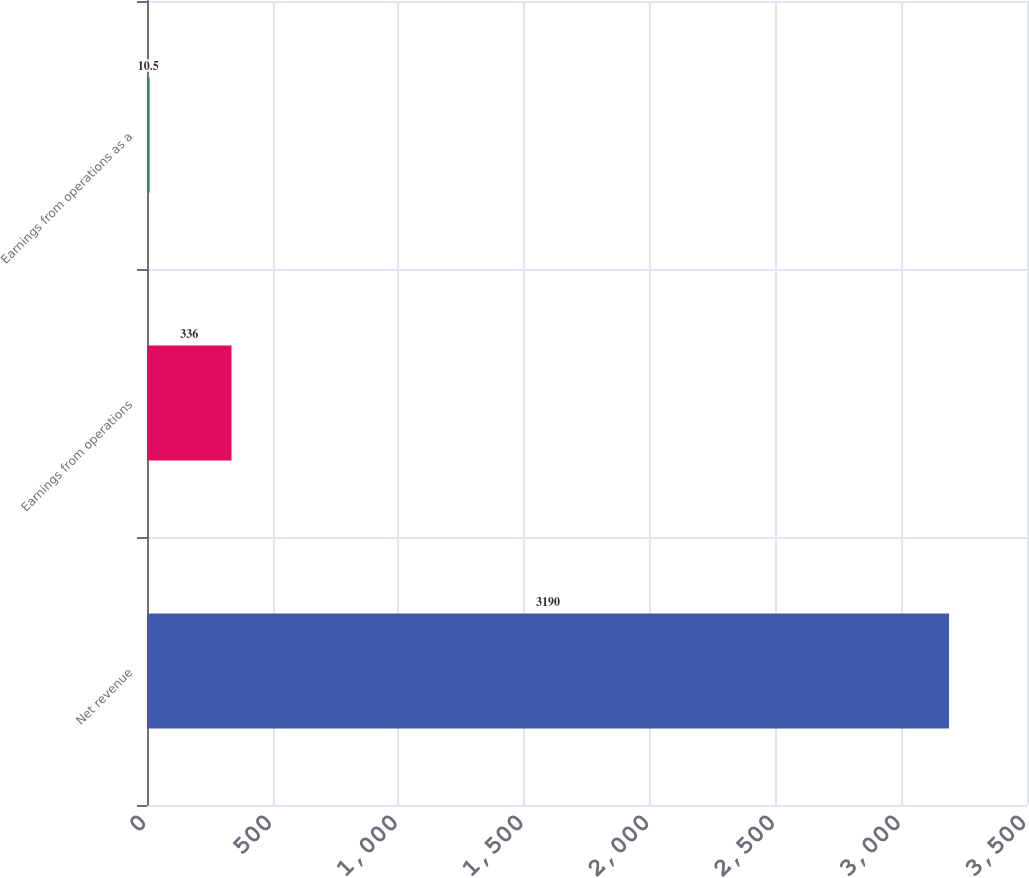Convert chart. <chart><loc_0><loc_0><loc_500><loc_500><bar_chart><fcel>Net revenue<fcel>Earnings from operations<fcel>Earnings from operations as a<nl><fcel>3190<fcel>336<fcel>10.5<nl></chart> 